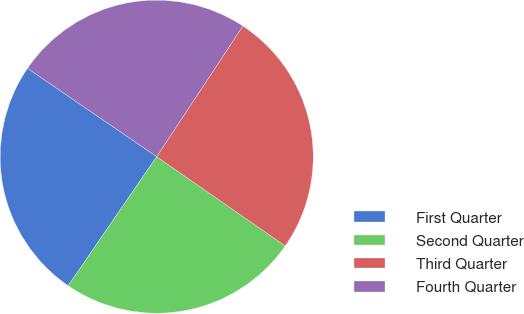<chart> <loc_0><loc_0><loc_500><loc_500><pie_chart><fcel>First Quarter<fcel>Second Quarter<fcel>Third Quarter<fcel>Fourth Quarter<nl><fcel>24.98%<fcel>24.91%<fcel>25.37%<fcel>24.74%<nl></chart> 